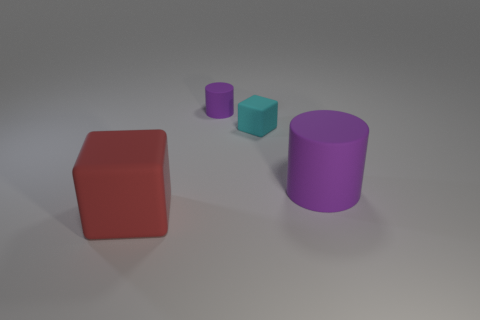How many other things are the same material as the small cyan cube?
Your answer should be compact. 3. Does the large object that is on the left side of the big cylinder have the same shape as the big thing behind the large cube?
Give a very brief answer. No. How many rubber things are left of the small cyan object and right of the large red thing?
Provide a short and direct response. 1. There is a purple thing that is the same size as the cyan block; what shape is it?
Your response must be concise. Cylinder. How many purple rubber cylinders have the same size as the cyan matte block?
Ensure brevity in your answer.  1. How many large red matte things have the same shape as the big purple matte object?
Your answer should be very brief. 0. What shape is the small object that is the same material as the small cube?
Your answer should be very brief. Cylinder. What is the shape of the large matte object that is on the right side of the matte cube that is in front of the matte thing that is to the right of the small cyan matte cube?
Ensure brevity in your answer.  Cylinder. Are there more tiny brown rubber balls than cubes?
Give a very brief answer. No. There is another thing that is the same shape as the big purple matte thing; what is its material?
Provide a succinct answer. Rubber. 